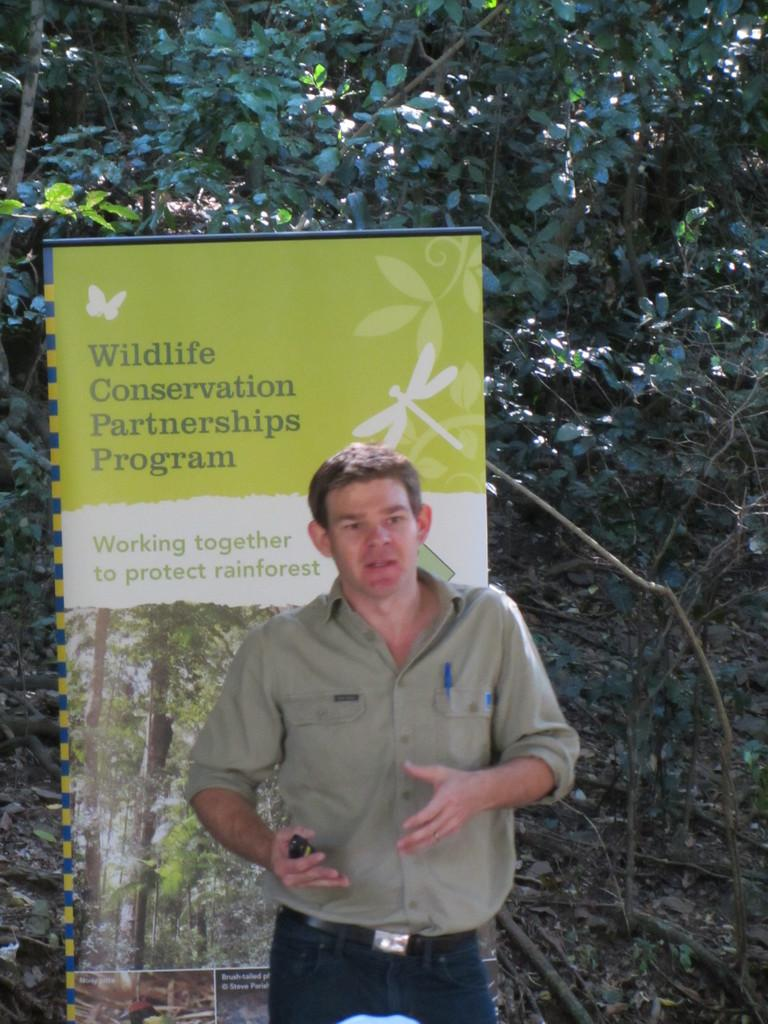What is the main subject of the image? There is a man standing in the image. What is the man wearing? The man is wearing clothes. What is the man holding in his hand? The man is holding an object in his hand. What can be seen on the wall in the image? There is a poster visible in the image, and there is text on the poster. What type of natural elements are present in the image? Dry leaves and trees are present in the image. What type of shoe is the man wearing in the image? The provided facts do not mention any shoes, so we cannot determine the type of shoe the man is wearing. What kind of jewel can be seen on the man's neck in the image? There is no mention of a jewel or any necklace in the provided facts, so we cannot determine if there is a jewel present in the image. 